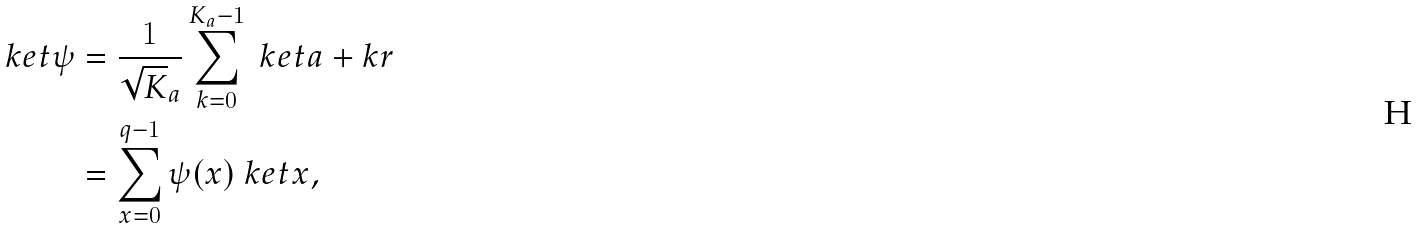<formula> <loc_0><loc_0><loc_500><loc_500>\ k e t { \psi } & = \frac { 1 } { \sqrt { K } _ { a } } \sum _ { k = 0 } ^ { K _ { a } - 1 } \ k e t { a + k r } \\ & = \sum _ { x = 0 } ^ { q - 1 } \psi ( x ) \ k e t { x } ,</formula> 